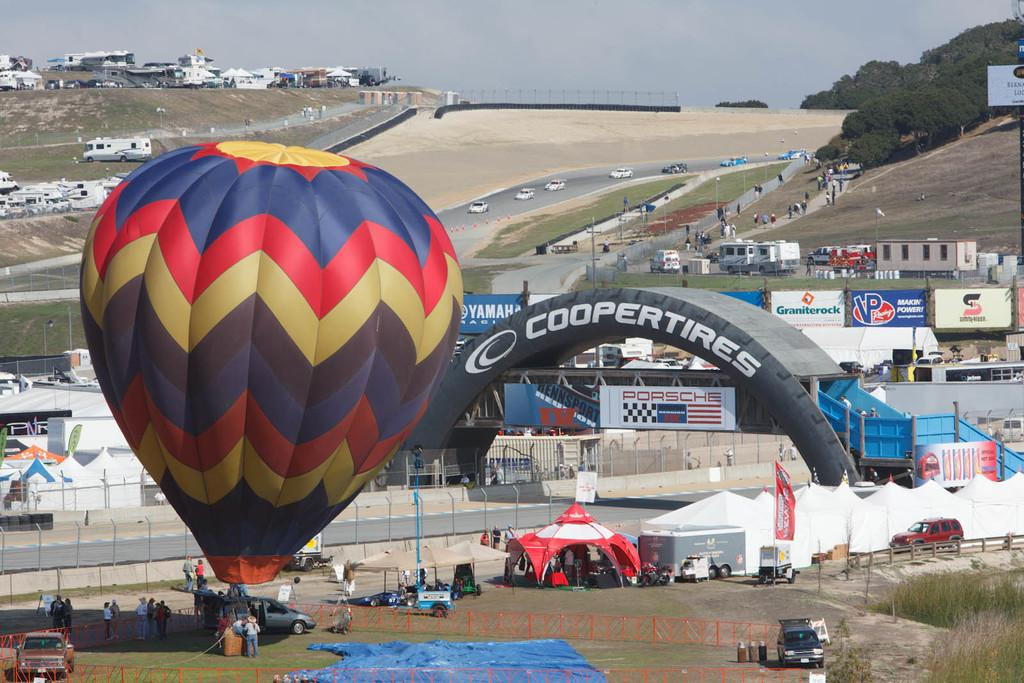<image>
Relay a brief, clear account of the picture shown. An archway that says Coopertires rises over a race track. 